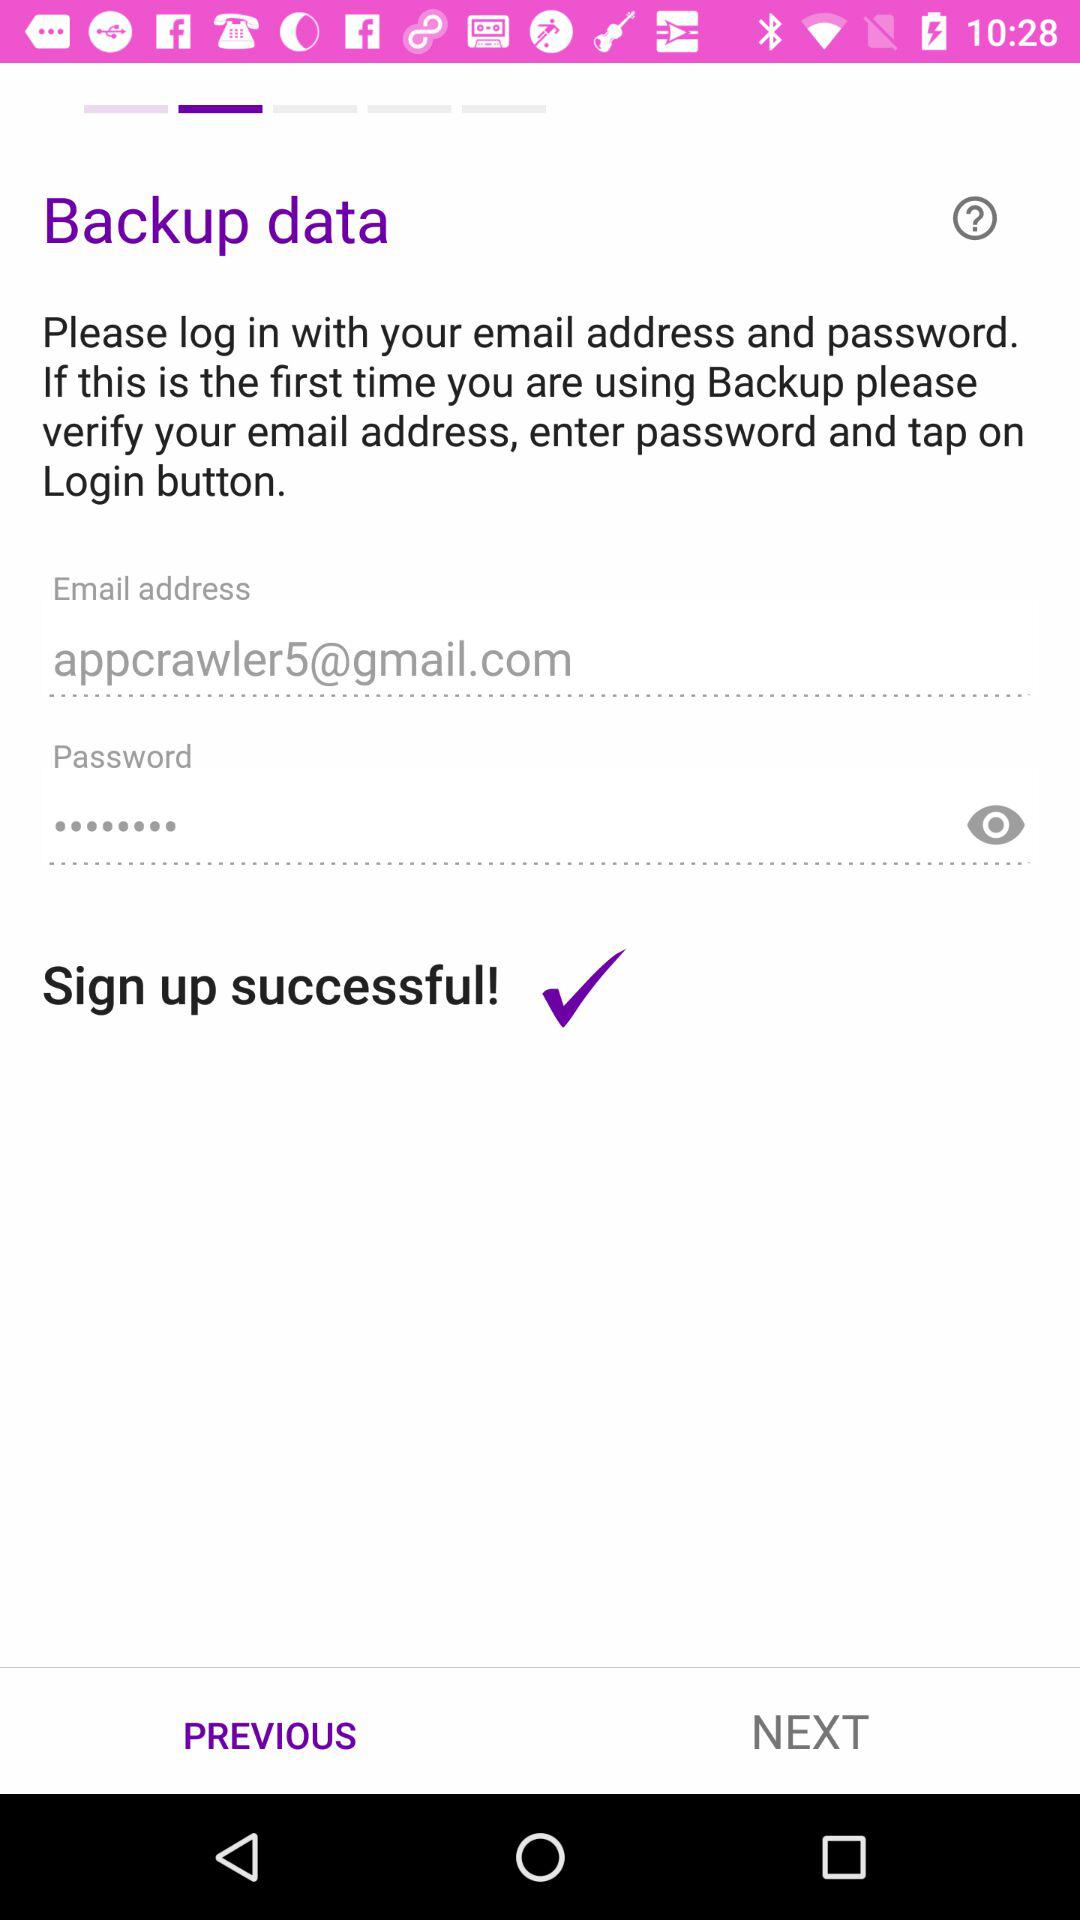What is the email address of the user? The email address is appcrawler5@gmail.com. 